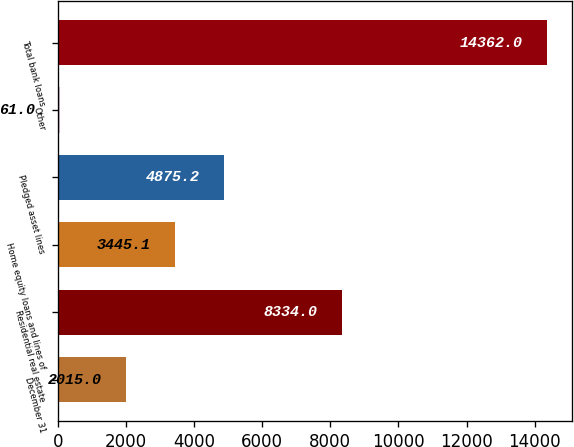Convert chart to OTSL. <chart><loc_0><loc_0><loc_500><loc_500><bar_chart><fcel>December 31<fcel>Residential real estate<fcel>Home equity loans and lines of<fcel>Pledged asset lines<fcel>Other<fcel>Total bank loans<nl><fcel>2015<fcel>8334<fcel>3445.1<fcel>4875.2<fcel>61<fcel>14362<nl></chart> 